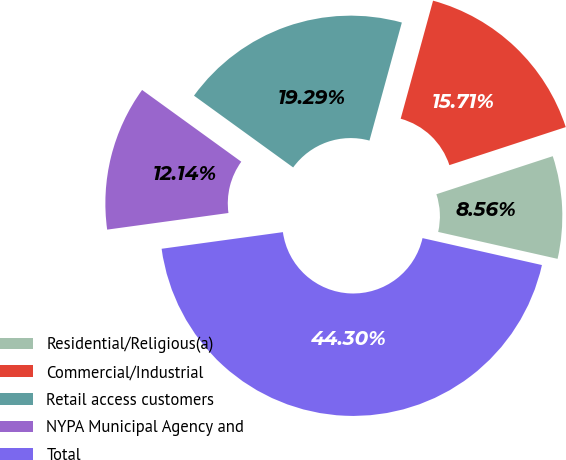<chart> <loc_0><loc_0><loc_500><loc_500><pie_chart><fcel>Residential/Religious(a)<fcel>Commercial/Industrial<fcel>Retail access customers<fcel>NYPA Municipal Agency and<fcel>Total<nl><fcel>8.56%<fcel>15.71%<fcel>19.29%<fcel>12.14%<fcel>44.3%<nl></chart> 